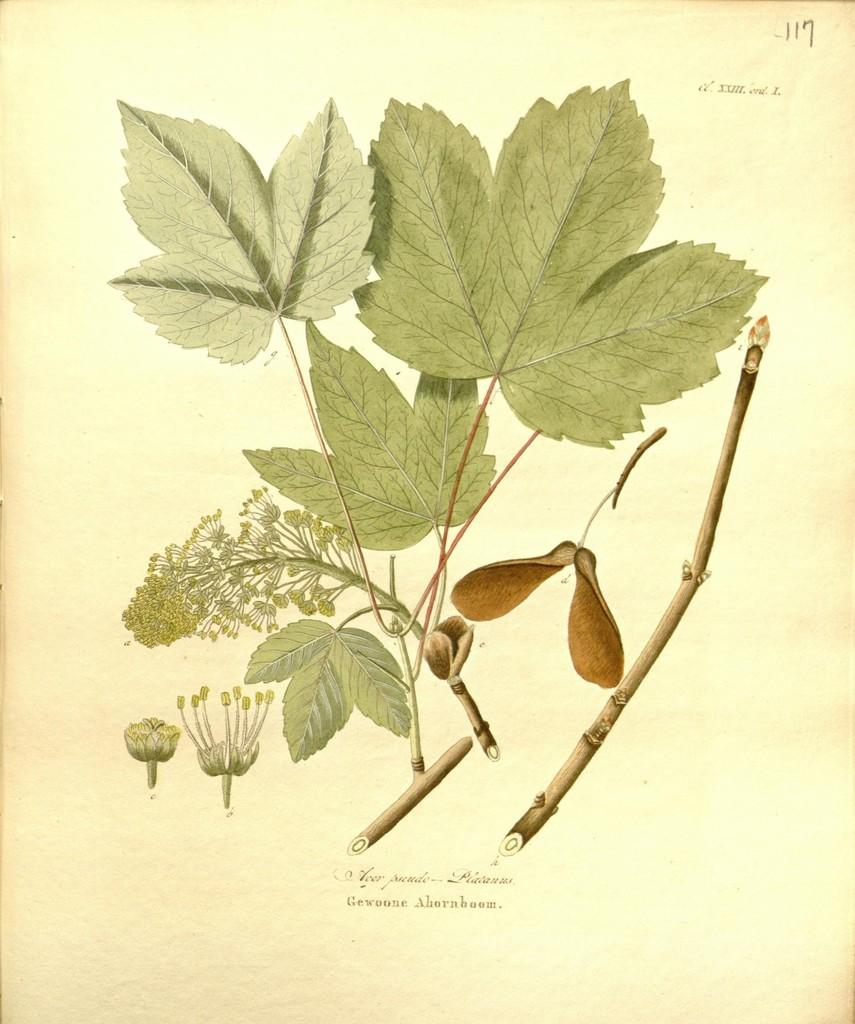What is the main subject of the paper in the image? The paper contains images of leaves, stems, and flowers. Can you describe the images on the paper in more detail? The images on the paper include leaves, stems, and flowers. What type of muscle can be seen flexing in the image? There is no muscle present in the image; it features a paper with images of leaves, stems, and flowers. What direction is the current flowing in the image? There is no current present in the image; it features a paper with images of leaves, stems, and flowers. 